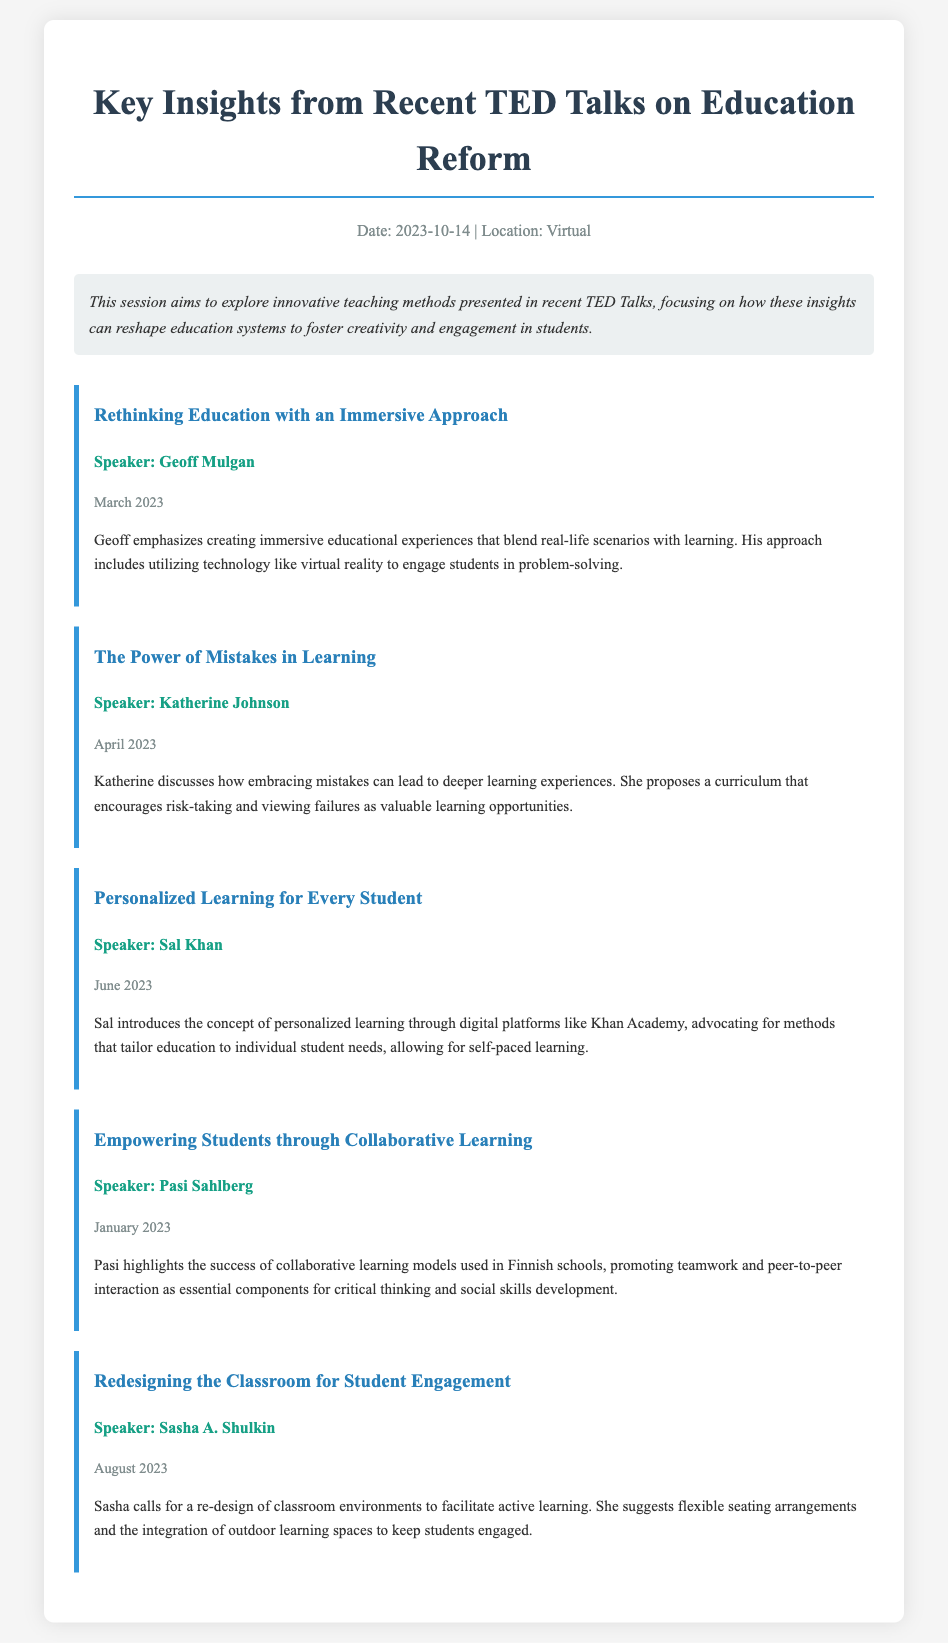what is the date of the session? The date of the session is mentioned in the meta section of the document.
Answer: 2023-10-14 who is the speaker for the "Personalized Learning for Every Student" session? The speaker's name can be found under the specific agenda item for that session.
Answer: Sal Khan what innovative technology does Geoff Mulgan propose for education? This information is found in the key insight of Geoff Mulgan's session regarding immersive education.
Answer: virtual reality which month did Katherine Johnson give her talk? The date of Katherine Johnson's talk is provided within her agenda item.
Answer: April 2023 what main theme does Pasi Sahlberg highlight in his talk? The key insight of Pasi's session indicates the focus area discussed.
Answer: collaborative learning how does Sasha A. Shulkin suggest redesigning classrooms? This information is included in the key insight of Sasha A. Shulkin's agenda item detailing classroom redesign.
Answer: flexible seating arrangements which country’s education model does Pasi Sahlberg refer to? Pasi mentions a specific education system in the context of successful collaborative learning models.
Answer: Finnish what is the focus of the TED Talks summarized in the document? The description section provides context on the main focus of the session.
Answer: innovative teaching methods 